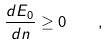<formula> <loc_0><loc_0><loc_500><loc_500>\frac { d E _ { 0 } } { d n } \geq 0 \quad ,</formula> 